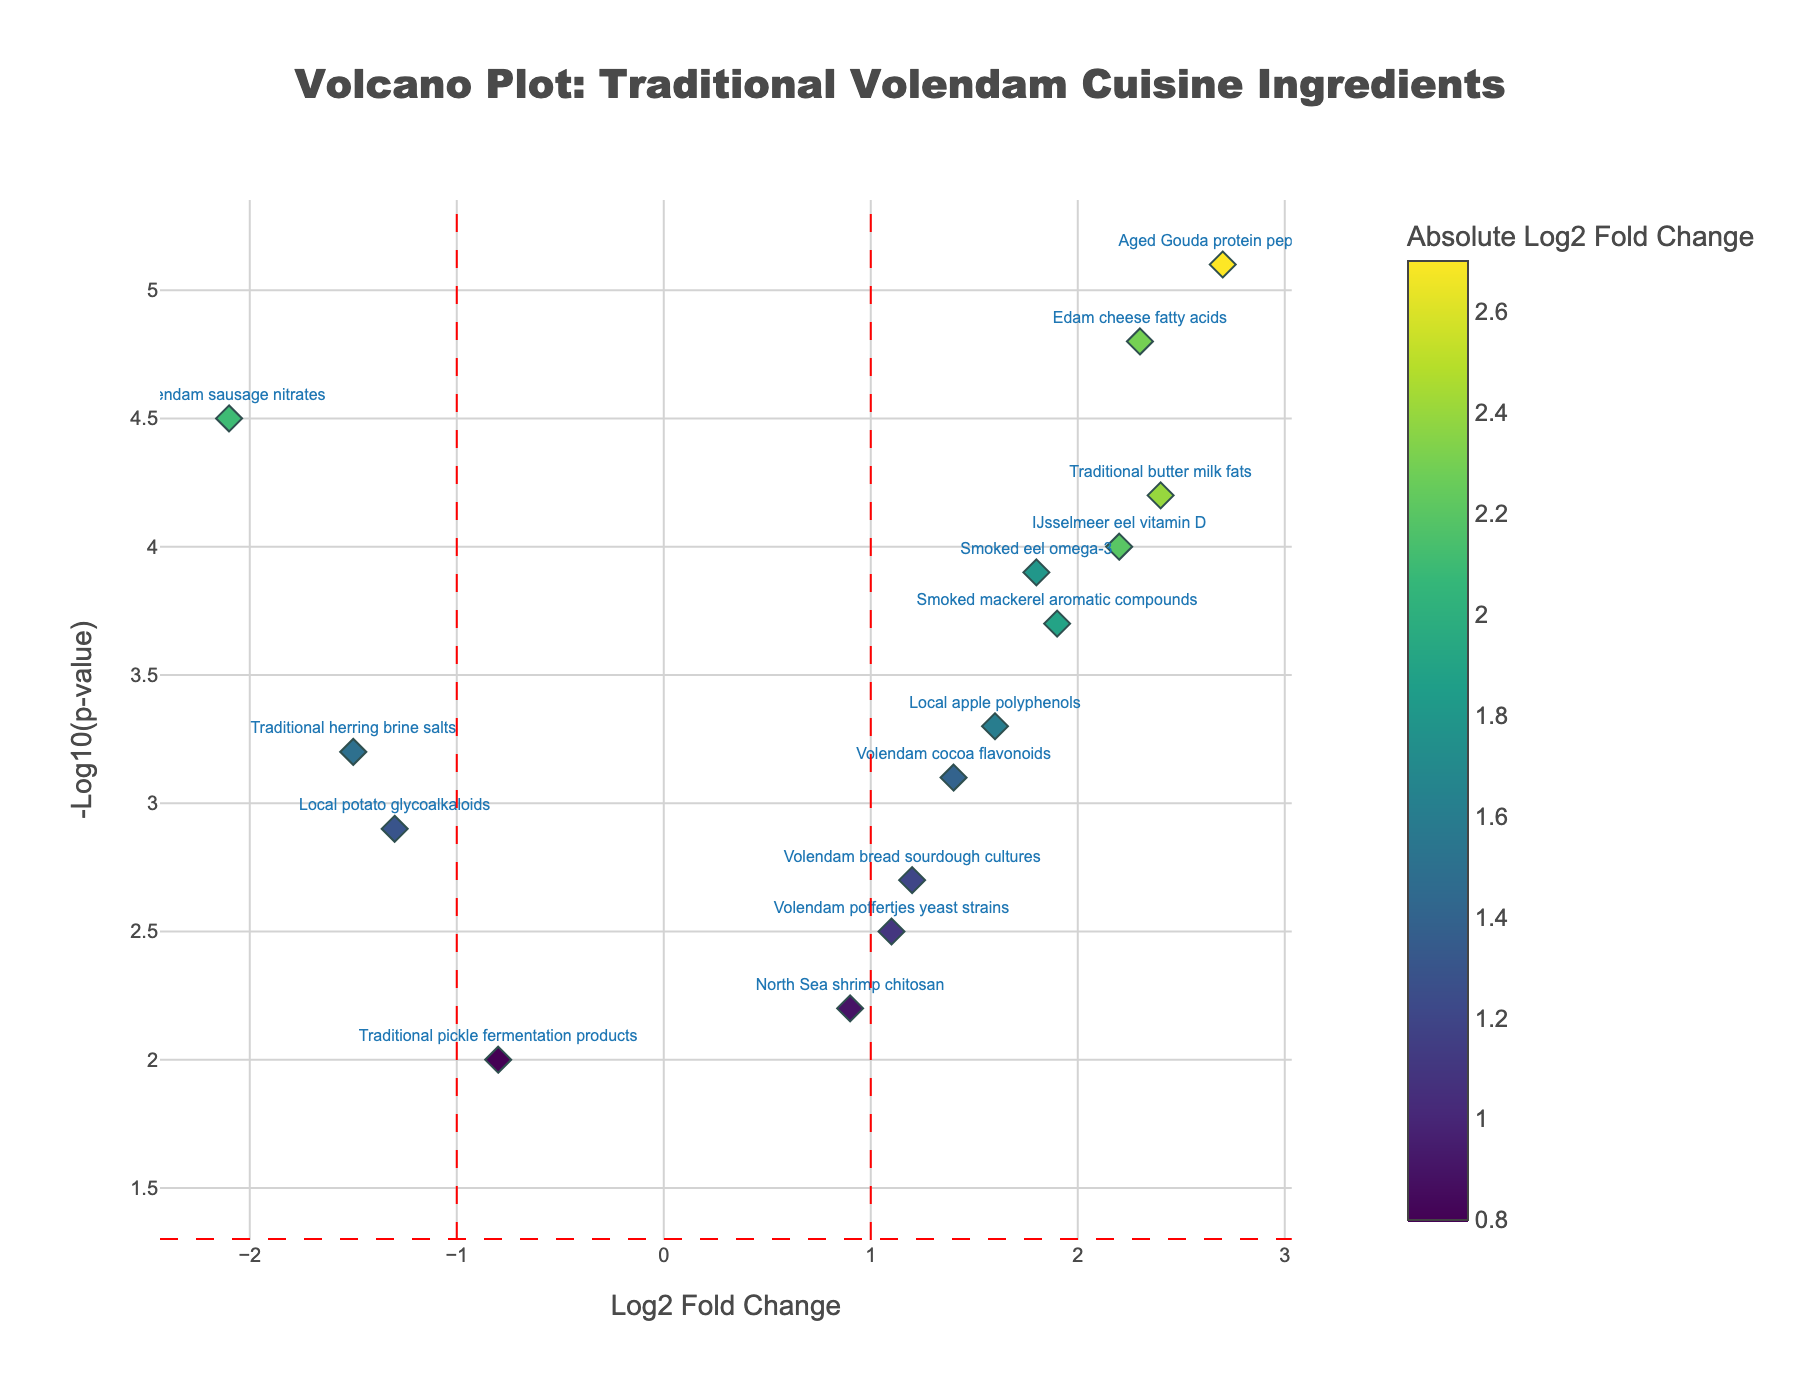What is the title of the plot? The title is displayed at the top of the plot. It summarizes what the plot is about.
Answer: Volcano Plot: Traditional Volendam Cuisine Ingredients How many compounds have a Log2 Fold Change greater than 2? Look at the x-axis and count the data points that are to the right of the value 2.
Answer: 4 Which compound has the highest -Log10(p-value)? Identify the highest point along the y-axis and read the corresponding compound label.
Answer: Aged Gouda protein peptides What is the median -Log10(p-value) of the data points? Arrange the -Log10(p-value) values in ascending order and find the middle value.
Answer: 3.3 How many compounds have significant differences in traditional vs. modern alternatives at p-value < 0.05? Refer to the horizontal threshold line at -Log10(0.05) ≈ 1.3 and count the data points above it.
Answer: 14 Which compound has the largest positive Log2 Fold Change and what is its -Log10(p-value)? Identify the data point farthest to the right on the x-axis and read its corresponding log fold change and p-value.
Answer: Aged Gouda protein peptides, 5.1 Are there more compounds with a positive or negative Log2 Fold Change? Count the number of data points on the positive side (right of zero) and compare it to the negative side (left of zero).
Answer: More with positive Which compound is closest to the origin (0,0)? Identify the data point with the smallest absolute values for both Log2 Fold Change and -Log10(p-value).
Answer: Traditional pickle fermentation products 